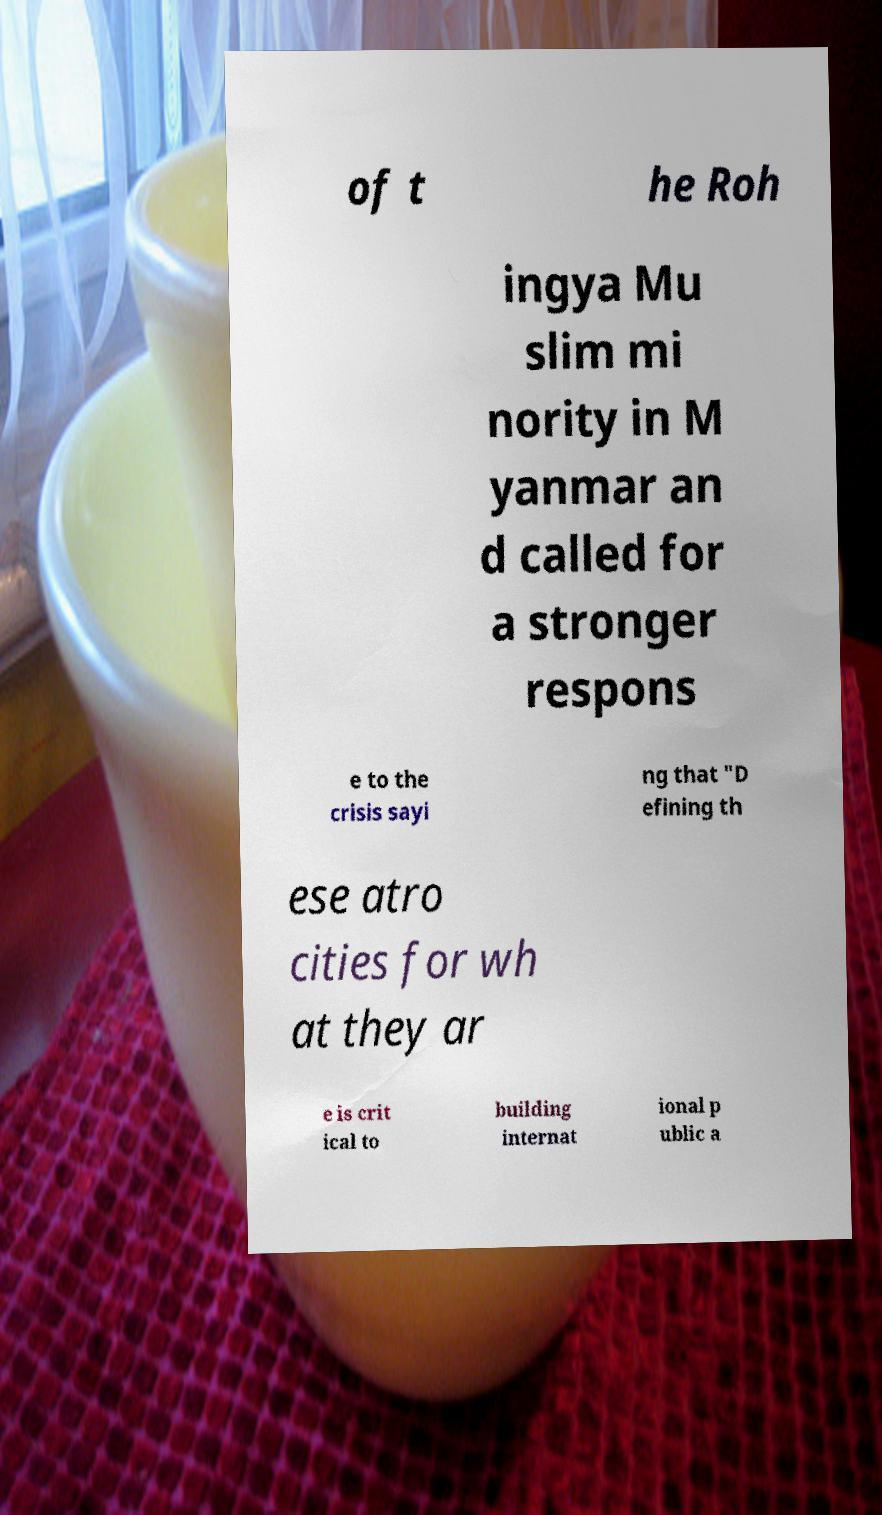Can you read and provide the text displayed in the image?This photo seems to have some interesting text. Can you extract and type it out for me? of t he Roh ingya Mu slim mi nority in M yanmar an d called for a stronger respons e to the crisis sayi ng that "D efining th ese atro cities for wh at they ar e is crit ical to building internat ional p ublic a 